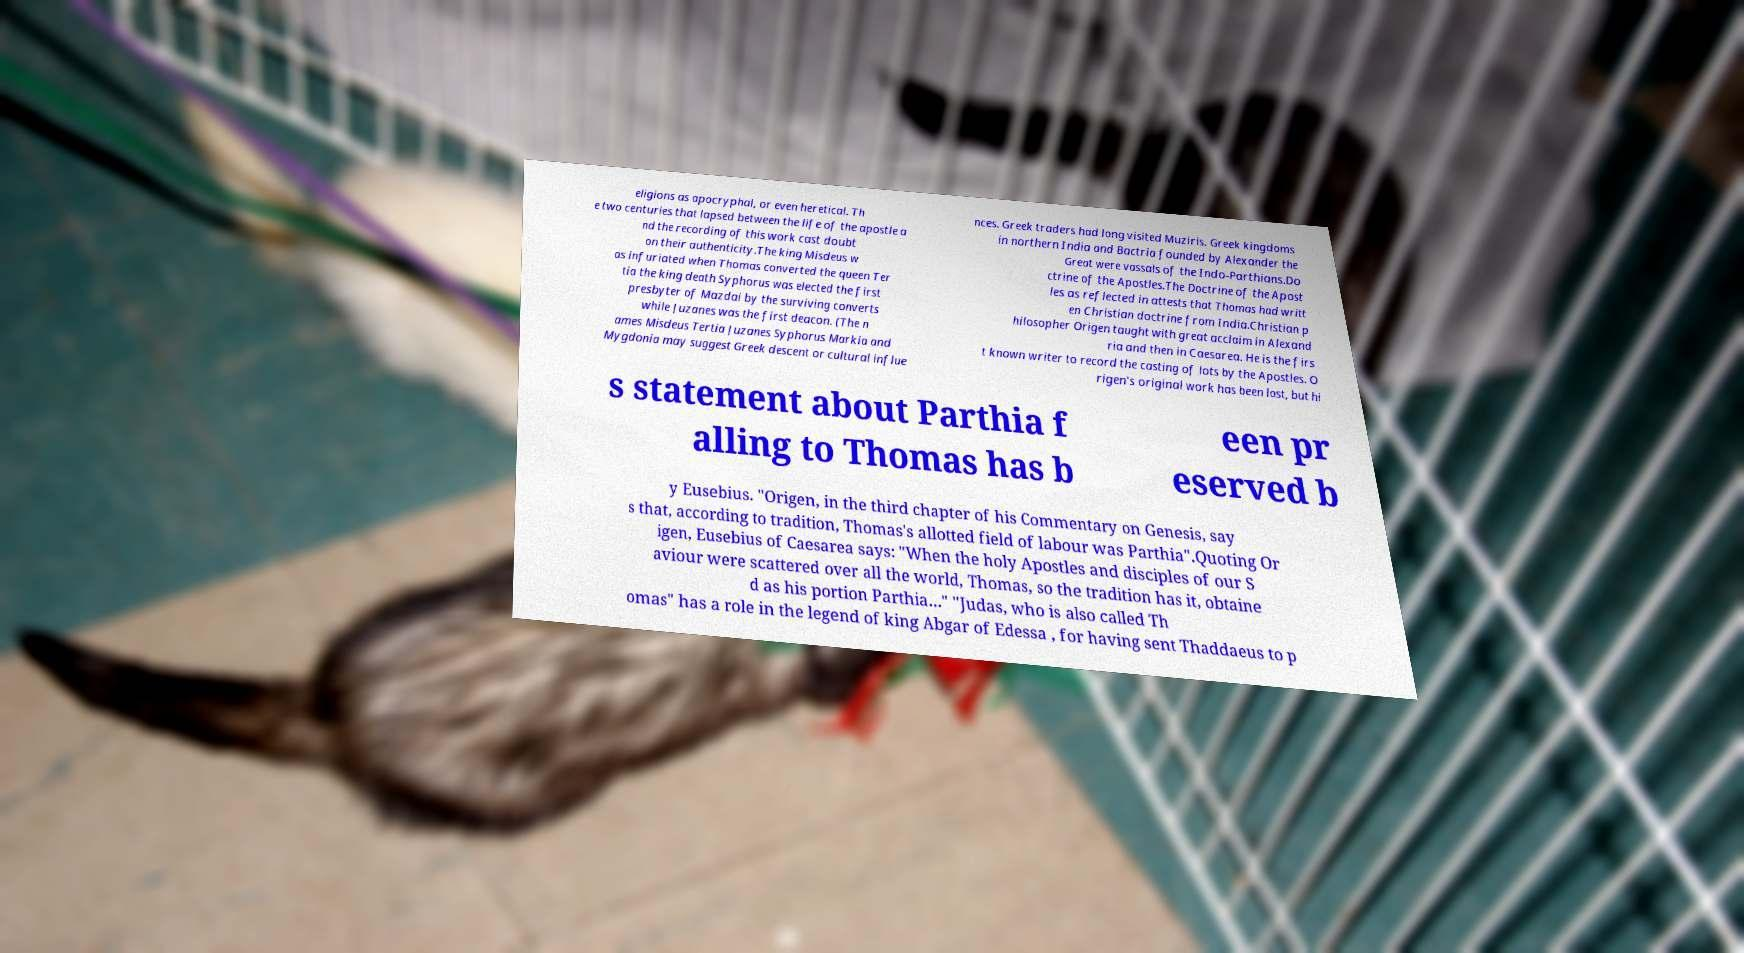Could you extract and type out the text from this image? eligions as apocryphal, or even heretical. Th e two centuries that lapsed between the life of the apostle a nd the recording of this work cast doubt on their authenticity.The king Misdeus w as infuriated when Thomas converted the queen Ter tia the king death Syphorus was elected the first presbyter of Mazdai by the surviving converts while Juzanes was the first deacon. (The n ames Misdeus Tertia Juzanes Syphorus Markia and Mygdonia may suggest Greek descent or cultural influe nces. Greek traders had long visited Muziris. Greek kingdoms in northern India and Bactria founded by Alexander the Great were vassals of the Indo-Parthians.Do ctrine of the Apostles.The Doctrine of the Apost les as reflected in attests that Thomas had writt en Christian doctrine from India.Christian p hilosopher Origen taught with great acclaim in Alexand ria and then in Caesarea. He is the firs t known writer to record the casting of lots by the Apostles. O rigen's original work has been lost, but hi s statement about Parthia f alling to Thomas has b een pr eserved b y Eusebius. "Origen, in the third chapter of his Commentary on Genesis, say s that, according to tradition, Thomas's allotted field of labour was Parthia".Quoting Or igen, Eusebius of Caesarea says: "When the holy Apostles and disciples of our S aviour were scattered over all the world, Thomas, so the tradition has it, obtaine d as his portion Parthia…" "Judas, who is also called Th omas" has a role in the legend of king Abgar of Edessa , for having sent Thaddaeus to p 